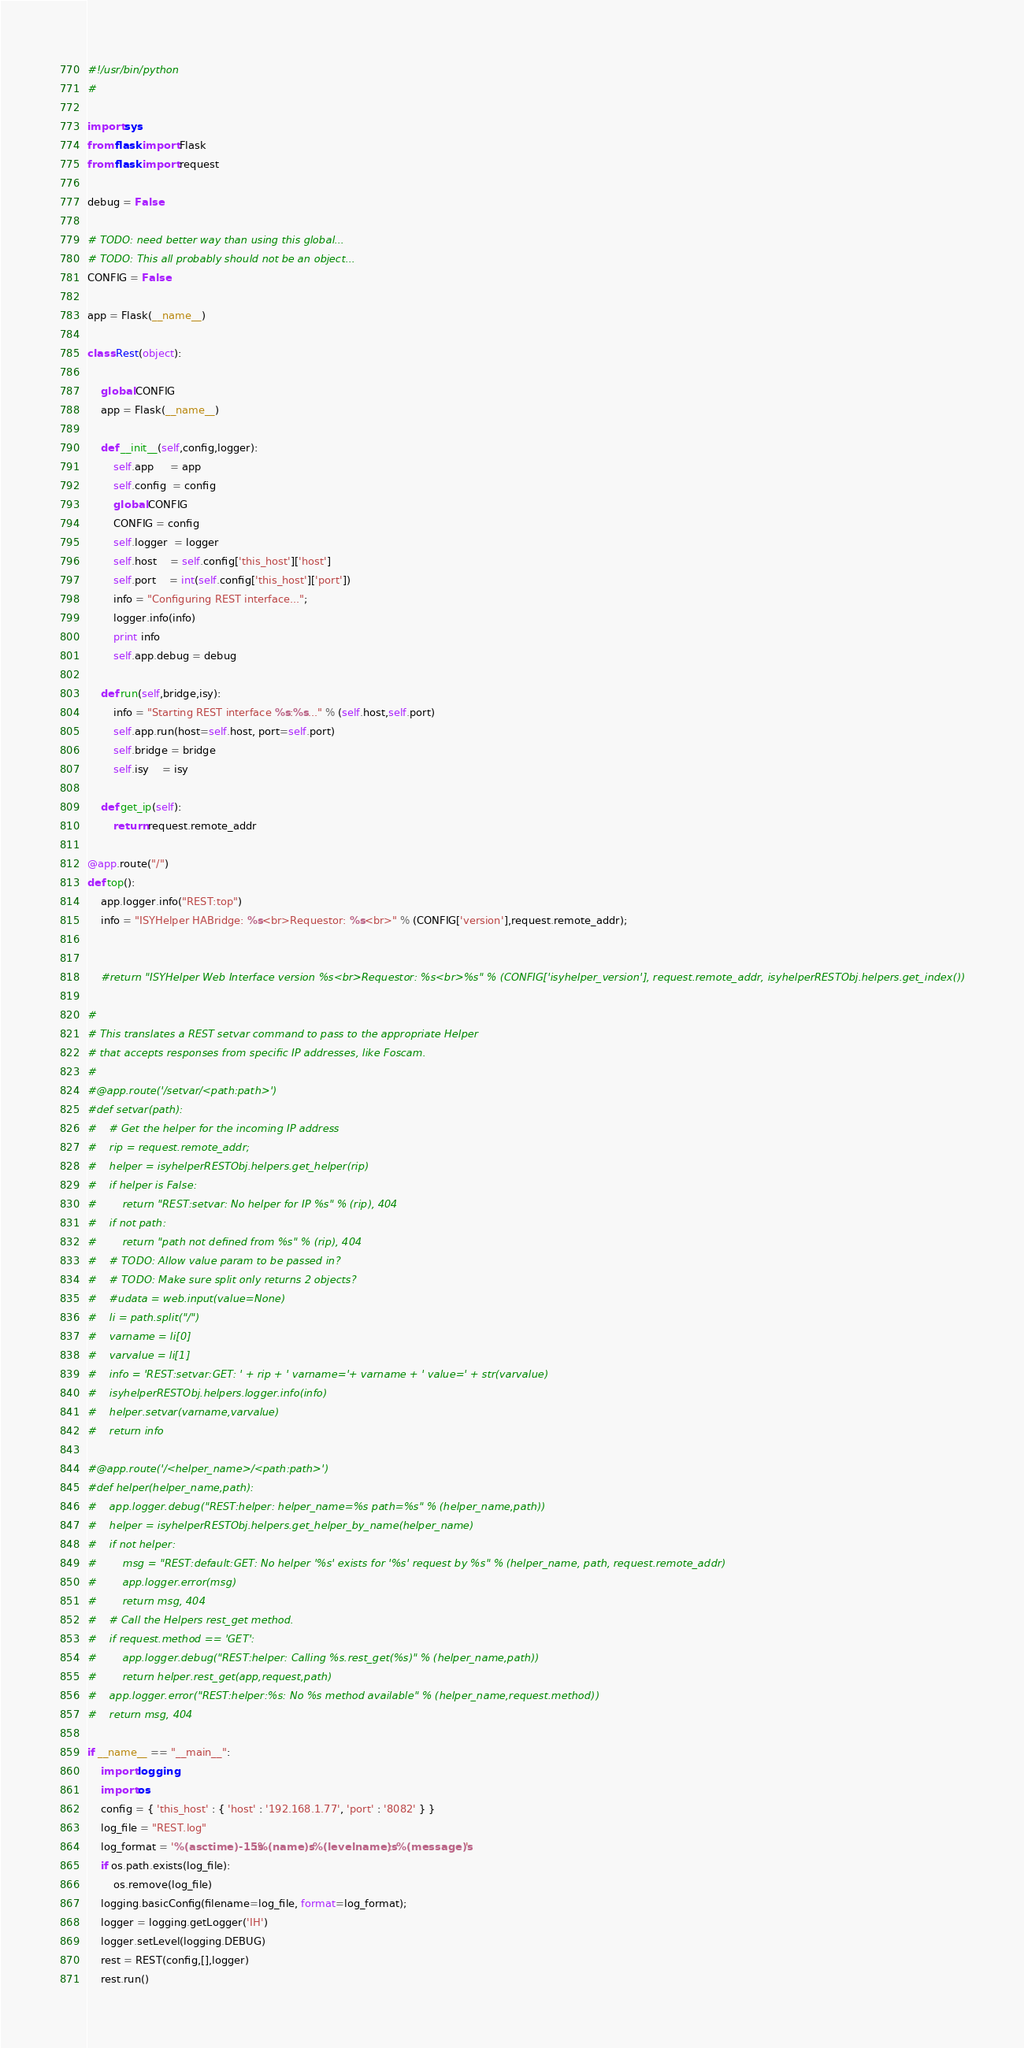Convert code to text. <code><loc_0><loc_0><loc_500><loc_500><_Python_>#!/usr/bin/python
#

import sys
from flask import Flask
from flask import request

debug = False

# TODO: need better way than using this global...
# TODO: This all probably should not be an object...
CONFIG = False

app = Flask(__name__)

class Rest(object):

    global CONFIG
    app = Flask(__name__)
    
    def __init__(self,config,logger):
        self.app     = app
        self.config  = config
        global CONFIG
        CONFIG = config
        self.logger  = logger
        self.host    = self.config['this_host']['host']
        self.port    = int(self.config['this_host']['port'])
        info = "Configuring REST interface...";
        logger.info(info)
        print info
        self.app.debug = debug

    def run(self,bridge,isy):
        info = "Starting REST interface %s:%s..." % (self.host,self.port)
        self.app.run(host=self.host, port=self.port)
        self.bridge = bridge
        self.isy    = isy

    def get_ip(self):
        return request.remote_addr

@app.route("/")
def top():
    app.logger.info("REST:top")
    info = "ISYHelper HABridge: %s<br>Requestor: %s<br>" % (CONFIG['version'],request.remote_addr);
    

    #return "ISYHelper Web Interface version %s<br>Requestor: %s<br>%s" % (CONFIG['isyhelper_version'], request.remote_addr, isyhelperRESTObj.helpers.get_index())

#
# This translates a REST setvar command to pass to the appropriate Helper
# that accepts responses from specific IP addresses, like Foscam.
#
#@app.route('/setvar/<path:path>')
#def setvar(path):
#    # Get the helper for the incoming IP address
#    rip = request.remote_addr;
#    helper = isyhelperRESTObj.helpers.get_helper(rip)
#    if helper is False:
#        return "REST:setvar: No helper for IP %s" % (rip), 404
#    if not path:
#        return "path not defined from %s" % (rip), 404
#    # TODO: Allow value param to be passed in?
#    # TODO: Make sure split only returns 2 objects?
#    #udata = web.input(value=None)
#    li = path.split("/")
#    varname = li[0]
#    varvalue = li[1]
#    info = 'REST:setvar:GET: ' + rip + ' varname='+ varname + ' value=' + str(varvalue)
#    isyhelperRESTObj.helpers.logger.info(info)
#    helper.setvar(varname,varvalue)
#    return info

#@app.route('/<helper_name>/<path:path>')
#def helper(helper_name,path):
#    app.logger.debug("REST:helper: helper_name=%s path=%s" % (helper_name,path))
#    helper = isyhelperRESTObj.helpers.get_helper_by_name(helper_name)
#    if not helper:
#        msg = "REST:default:GET: No helper '%s' exists for '%s' request by %s" % (helper_name, path, request.remote_addr)
#        app.logger.error(msg)
#        return msg, 404
#    # Call the Helpers rest_get method.
#    if request.method == 'GET':
#        app.logger.debug("REST:helper: Calling %s.rest_get(%s)" % (helper_name,path))
#        return helper.rest_get(app,request,path)
#    app.logger.error("REST:helper:%s: No %s method available" % (helper_name,request.method))
#    return msg, 404

if __name__ == "__main__":
    import logging
    import os
    config = { 'this_host' : { 'host' : '192.168.1.77', 'port' : '8082' } }
    log_file = "REST.log"
    log_format = '%(asctime)-15s:%(name)s:%(levelname)s: %(message)s'
    if os.path.exists(log_file):
        os.remove(log_file)
    logging.basicConfig(filename=log_file, format=log_format);
    logger = logging.getLogger('IH')
    logger.setLevel(logging.DEBUG)
    rest = REST(config,[],logger)
    rest.run()
</code> 